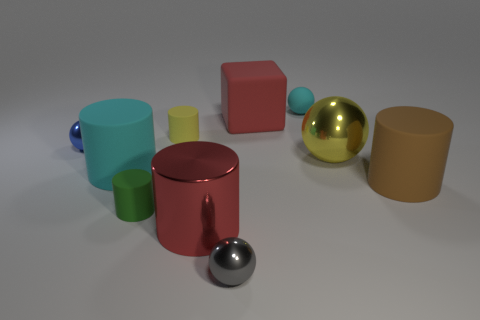Subtract all yellow spheres. How many spheres are left? 3 Subtract all gray spheres. How many spheres are left? 3 Subtract all balls. How many objects are left? 6 Subtract 1 spheres. How many spheres are left? 3 Add 4 small gray metal spheres. How many small gray metal spheres exist? 5 Subtract 0 gray cylinders. How many objects are left? 10 Subtract all gray spheres. Subtract all gray cylinders. How many spheres are left? 3 Subtract all gray metallic balls. Subtract all large yellow metal objects. How many objects are left? 8 Add 8 big red rubber objects. How many big red rubber objects are left? 9 